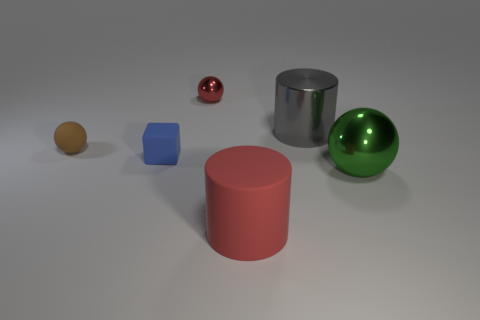Are there fewer big green rubber cubes than large cylinders?
Your answer should be compact. Yes. How many rubber things are the same shape as the big gray shiny thing?
Your answer should be compact. 1. What is the color of the other sphere that is the same size as the brown sphere?
Keep it short and to the point. Red. Are there the same number of small blue cubes that are behind the tiny brown sphere and red shiny objects that are in front of the big green shiny sphere?
Your answer should be compact. Yes. Are there any green blocks that have the same size as the green shiny object?
Offer a terse response. No. What size is the green thing?
Ensure brevity in your answer.  Large. Are there an equal number of rubber cylinders that are left of the large red cylinder and big gray balls?
Ensure brevity in your answer.  Yes. How many other things are there of the same color as the tiny rubber sphere?
Provide a succinct answer. 0. There is a tiny thing that is both behind the tiny blue cube and on the left side of the red metal sphere; what is its color?
Make the answer very short. Brown. What size is the ball on the right side of the metallic sphere behind the metallic ball in front of the small red shiny object?
Provide a succinct answer. Large. 